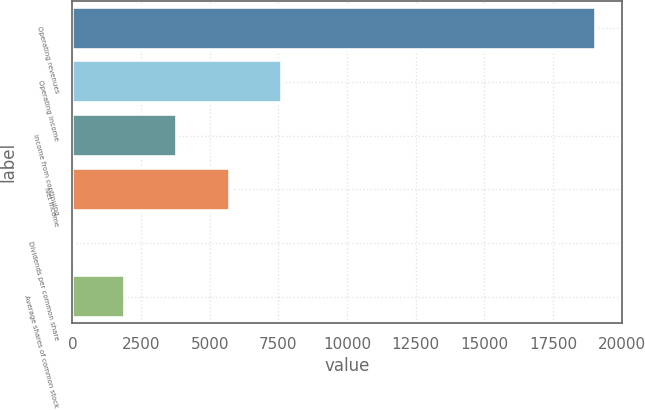Convert chart. <chart><loc_0><loc_0><loc_500><loc_500><bar_chart><fcel>Operating revenues<fcel>Operating income<fcel>Income from continuing<fcel>Net income<fcel>Dividends per common share<fcel>Average shares of common stock<nl><fcel>19063<fcel>7626.46<fcel>3814.28<fcel>5720.37<fcel>2.1<fcel>1908.19<nl></chart> 